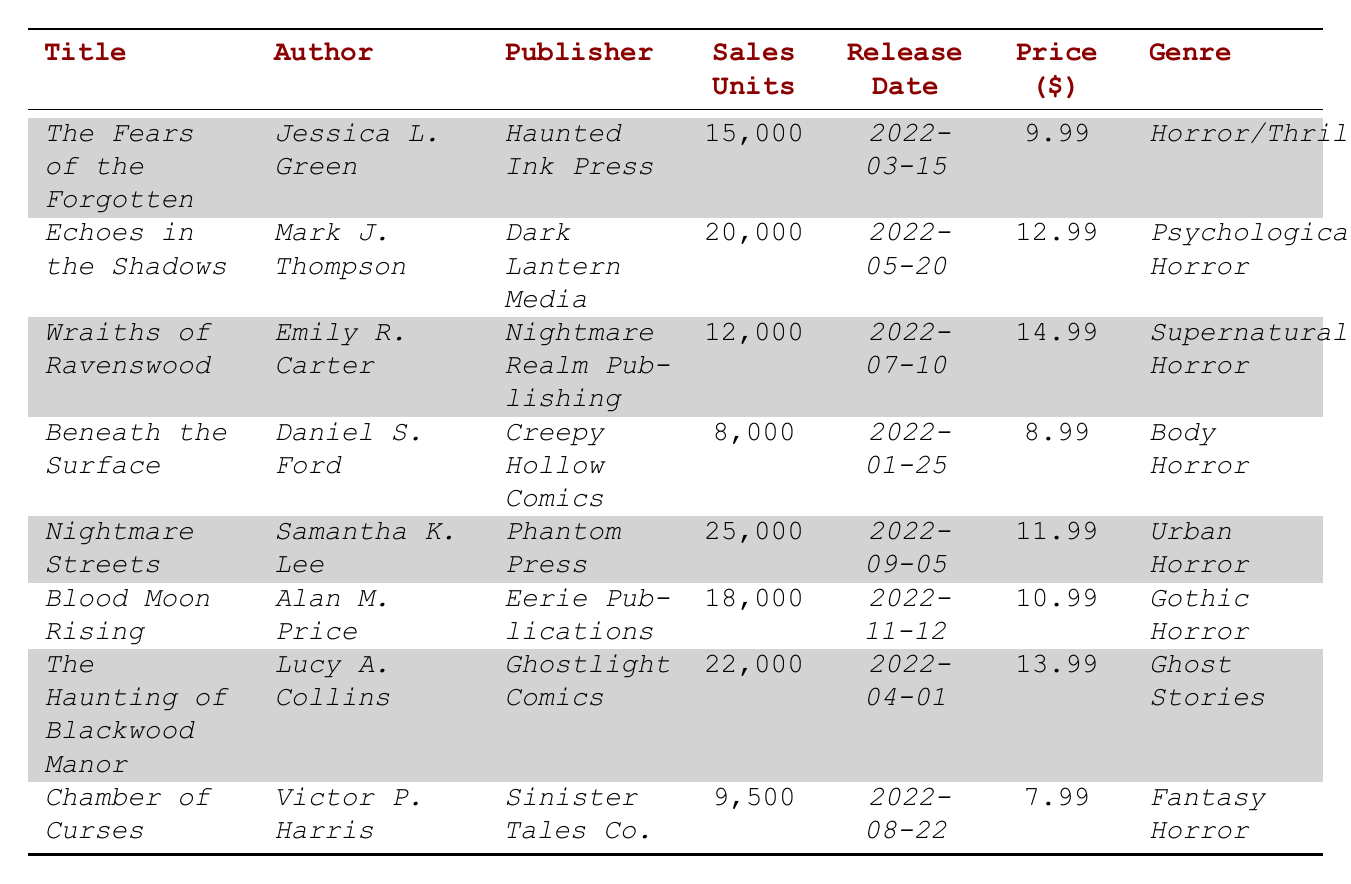What is the title of the comic book with the highest sales units? Looking through the table, I can see that *Nightmare Streets* has the highest sales units with 25,000.
Answer: *Nightmare Streets* Which author wrote *The Haunting of Blackwood Manor*? The table directly states that *The Haunting of Blackwood Manor* was written by *Lucy A. Collins*.
Answer: *Lucy A. Collins* How much did *Beneath the Surface* sell for? By checking the price column, *Beneath the Surface* is listed at $8.99.
Answer: $8.99 What is the genre of *Wraiths of Ravenswood*? The genre listed in the table for *Wraiths of Ravenswood* is *Supernatural Horror*.
Answer: *Supernatural Horror* Which comic book had the lowest sales units? I can compare the sales units, and it appears that *Beneath the Surface* had the lowest sales with 8,000 units.
Answer: *Beneath the Surface* What is the average price of all the comic books listed? The prices are $9.99, $12.99, $14.99, $8.99, $11.99, $10.99, $13.99, and $7.99. Adding these gives a total of $89.92. There are 8 titles, so the average price is $89.92 / 8 = $11.24.
Answer: $11.24 How many total units were sold across all comic books? I will sum the sales units from each comic title: 15,000 + 20,000 + 12,000 + 8,000 + 25,000 + 18,000 + 22,000 + 9,500 = 129,500 total units sold.
Answer: 129,500 Was *Echoes in the Shadows* released before *Blood Moon Rising*? Checking the release dates, *Echoes in the Shadows* was released on 2022-05-20 and *Blood Moon Rising* on 2022-11-12, meaning the former was released before the latter.
Answer: Yes Which two comic books were published by *Haunted Ink Press*? From the table, I see only *The Fears of the Forgotten* is published by *Haunted Ink Press*, meaning there’s just one title from this publisher, not two.
Answer: None Which genre has the highest total sales units? For this, I need to add the sales units by genre: Horror/Thriller (15,000), Psychological Horror (20,000), Supernatural Horror (12,000), Body Horror (8,000), Urban Horror (25,000), Gothic Horror (18,000), Ghost Stories (22,000), Fantasy Horror (9,500). Adding these gives 129,500. The Urban Horror genre has the highest units sold (25,000).
Answer: *Urban Horror* What is the difference in sales units between *Chamber of Curses* and *The Haunting of Blackwood Manor*? I will subtract the sales of *Chamber of Curses* (9,500) from *The Haunting of Blackwood Manor* (22,000): 22,000 - 9,500 = 12,500.
Answer: 12,500 